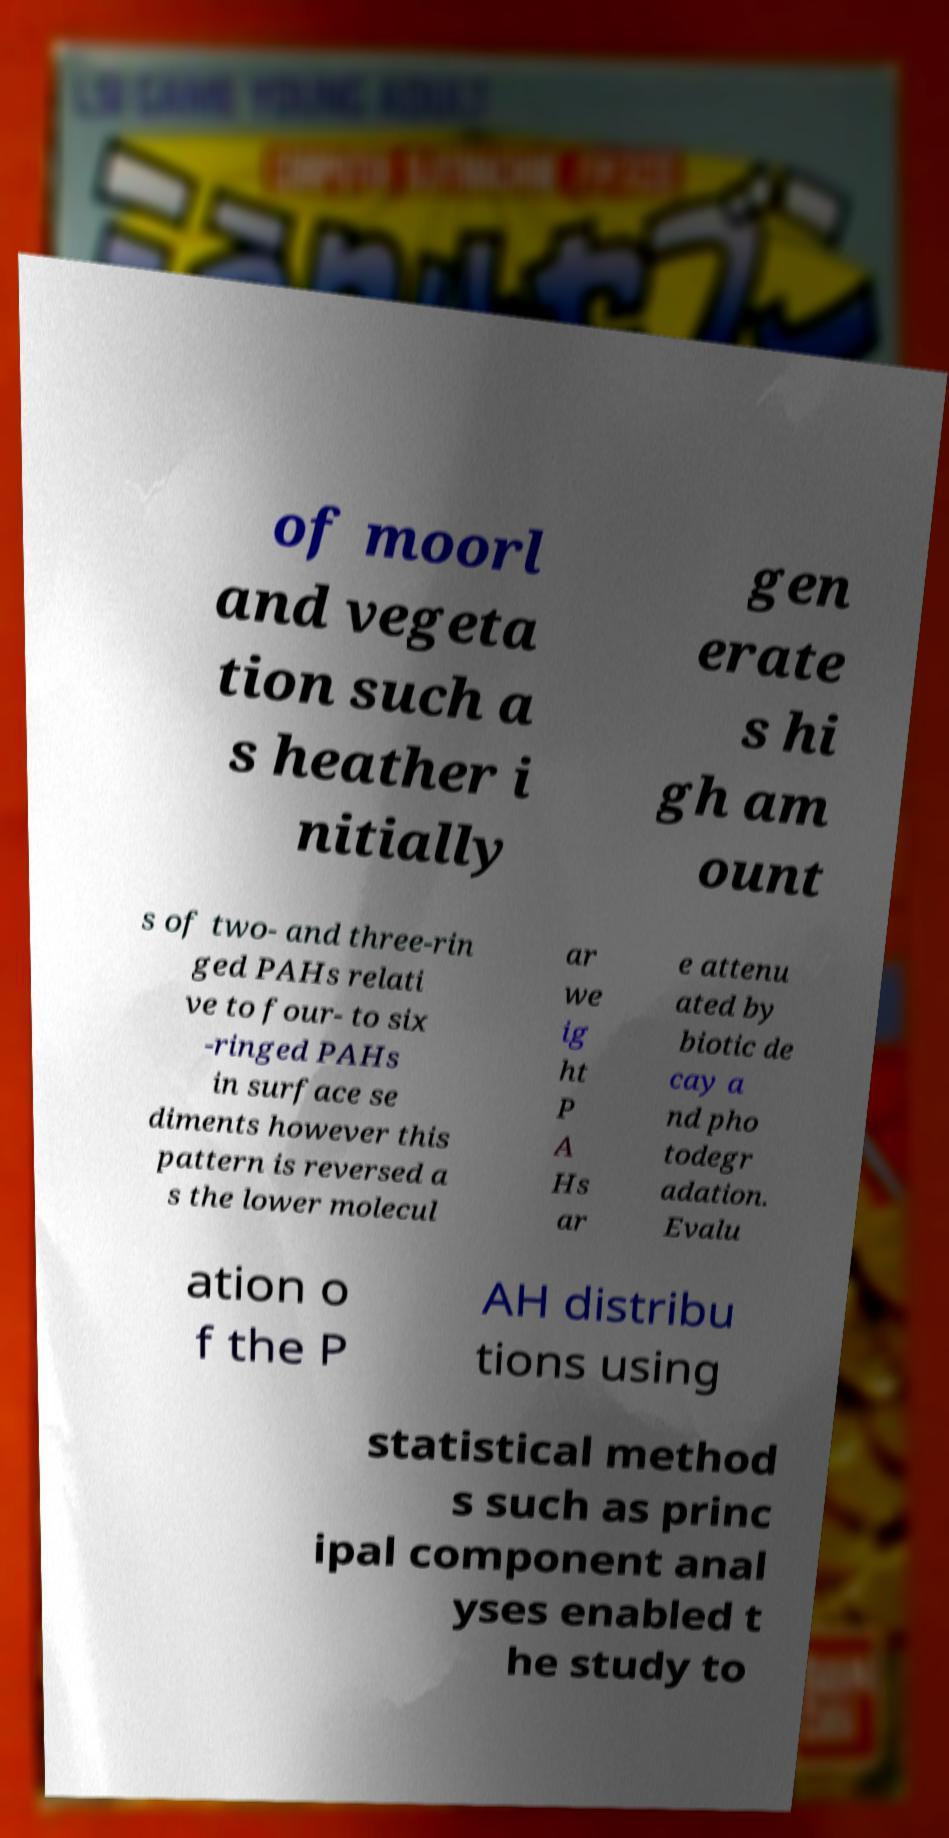Can you read and provide the text displayed in the image?This photo seems to have some interesting text. Can you extract and type it out for me? of moorl and vegeta tion such a s heather i nitially gen erate s hi gh am ount s of two- and three-rin ged PAHs relati ve to four- to six -ringed PAHs in surface se diments however this pattern is reversed a s the lower molecul ar we ig ht P A Hs ar e attenu ated by biotic de cay a nd pho todegr adation. Evalu ation o f the P AH distribu tions using statistical method s such as princ ipal component anal yses enabled t he study to 